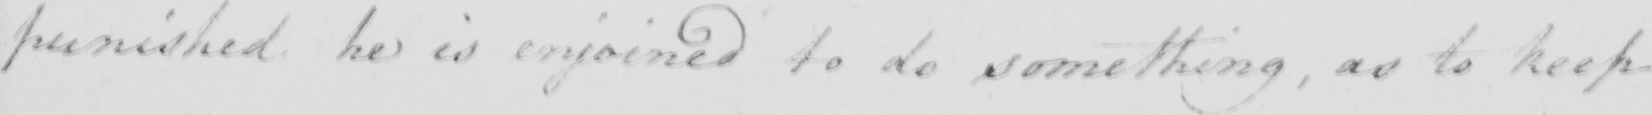Can you tell me what this handwritten text says? punished he is enjoined to do something , as to keep 